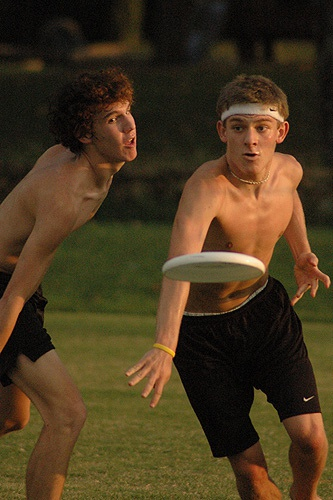Describe the objects in this image and their specific colors. I can see people in black, olive, maroon, and tan tones, people in black, maroon, and brown tones, and frisbee in black, olive, darkgray, tan, and gray tones in this image. 